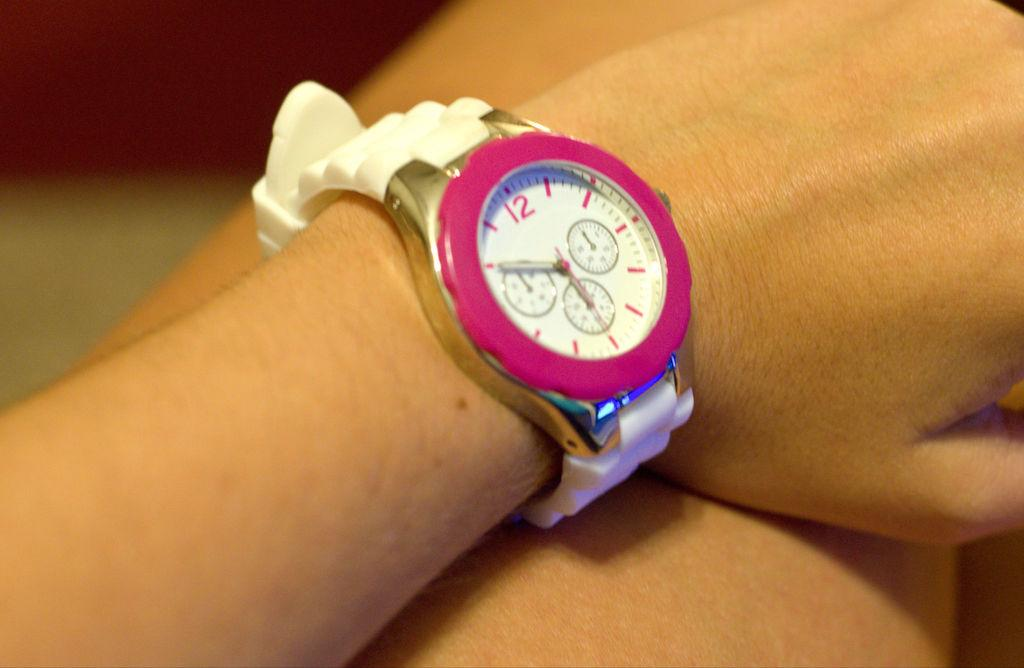<image>
Offer a succinct explanation of the picture presented. A girl is wearing a watch that is set to 5:50. 